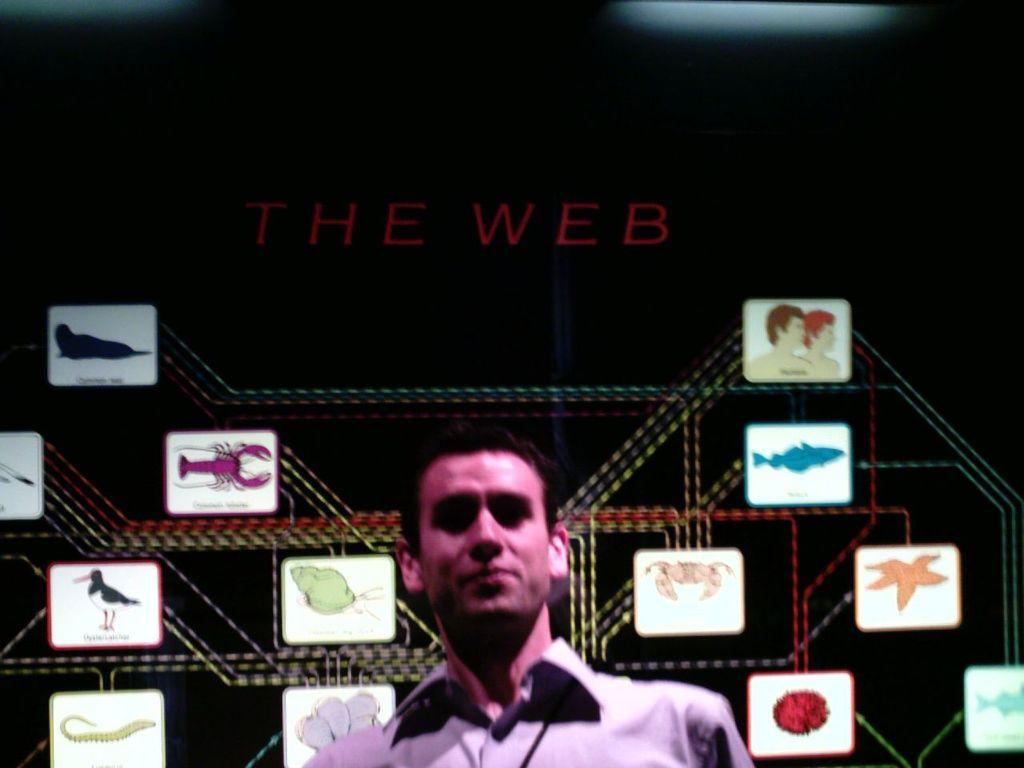What is the main subject of the image? There is a person in the image. What can be seen on the walls in the image? There are wall paintings in the image. What is written or drawn on the person or the walls? There is text in the image. What type of material is present in the image? Metal rods are present in the image. How would you describe the overall color of the image? The image has a dark color. Based on the darkness of the image, when might it have been taken? The image may have been taken during the night. What type of tomatoes are being displayed on the stage in the image? There is no stage or tomatoes present in the image. 